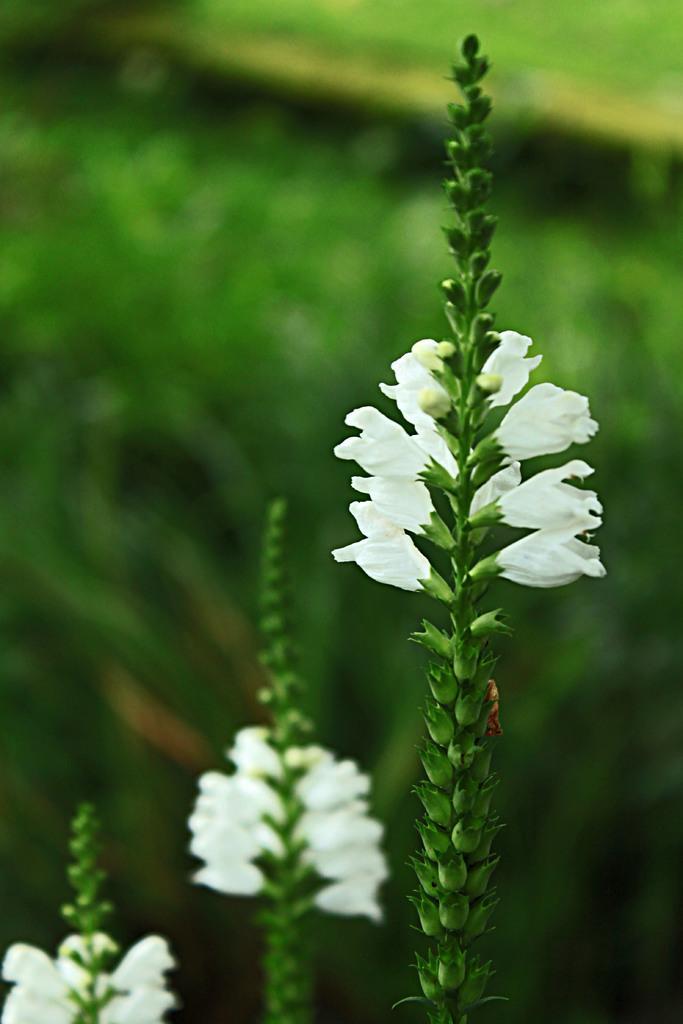How would you summarize this image in a sentence or two? In the picture we can see three plants with white color flowers to it and behind it, we can see, full of plants which are not clearly visible. 